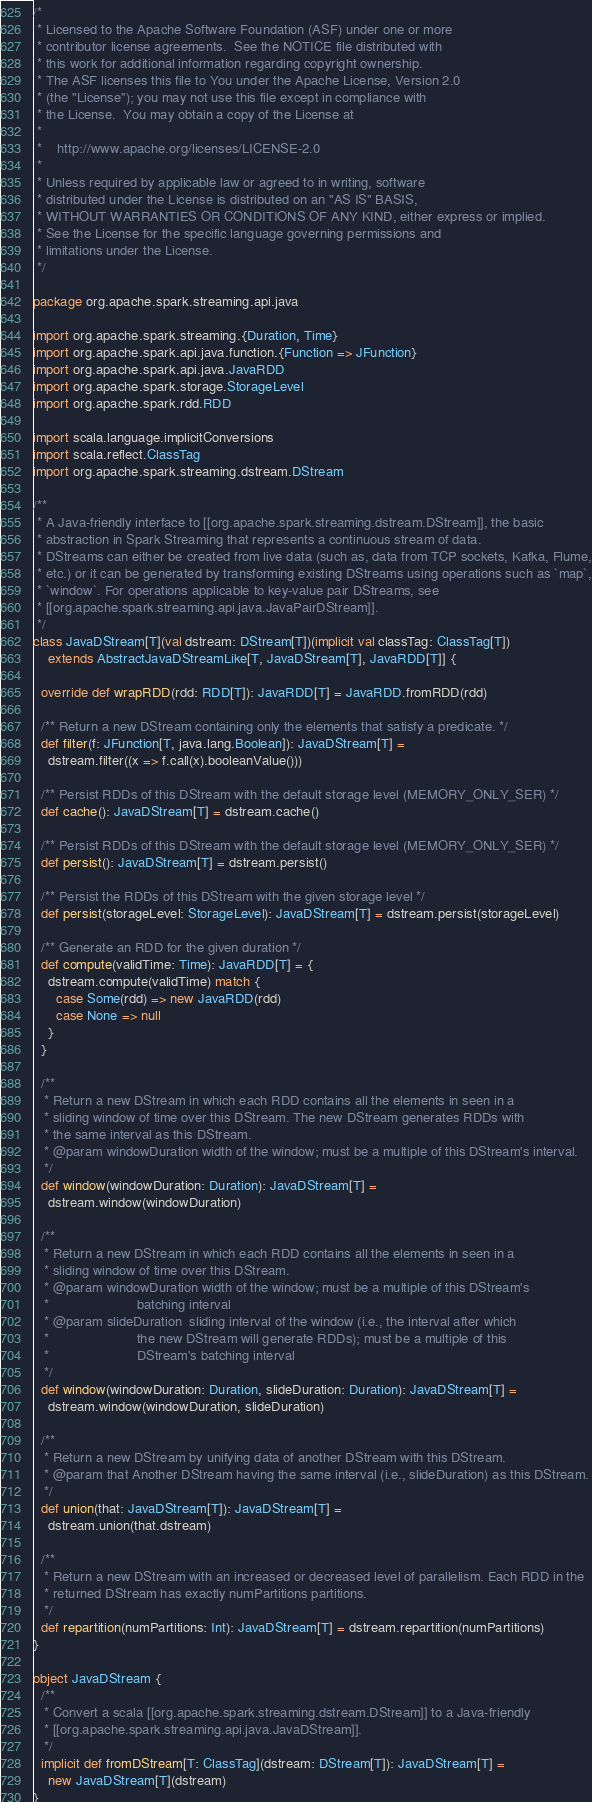<code> <loc_0><loc_0><loc_500><loc_500><_Scala_>/*
 * Licensed to the Apache Software Foundation (ASF) under one or more
 * contributor license agreements.  See the NOTICE file distributed with
 * this work for additional information regarding copyright ownership.
 * The ASF licenses this file to You under the Apache License, Version 2.0
 * (the "License"); you may not use this file except in compliance with
 * the License.  You may obtain a copy of the License at
 *
 *    http://www.apache.org/licenses/LICENSE-2.0
 *
 * Unless required by applicable law or agreed to in writing, software
 * distributed under the License is distributed on an "AS IS" BASIS,
 * WITHOUT WARRANTIES OR CONDITIONS OF ANY KIND, either express or implied.
 * See the License for the specific language governing permissions and
 * limitations under the License.
 */

package org.apache.spark.streaming.api.java

import org.apache.spark.streaming.{Duration, Time}
import org.apache.spark.api.java.function.{Function => JFunction}
import org.apache.spark.api.java.JavaRDD
import org.apache.spark.storage.StorageLevel
import org.apache.spark.rdd.RDD

import scala.language.implicitConversions
import scala.reflect.ClassTag
import org.apache.spark.streaming.dstream.DStream

/**
 * A Java-friendly interface to [[org.apache.spark.streaming.dstream.DStream]], the basic
 * abstraction in Spark Streaming that represents a continuous stream of data.
 * DStreams can either be created from live data (such as, data from TCP sockets, Kafka, Flume,
 * etc.) or it can be generated by transforming existing DStreams using operations such as `map`,
 * `window`. For operations applicable to key-value pair DStreams, see
 * [[org.apache.spark.streaming.api.java.JavaPairDStream]].
 */
class JavaDStream[T](val dstream: DStream[T])(implicit val classTag: ClassTag[T])
    extends AbstractJavaDStreamLike[T, JavaDStream[T], JavaRDD[T]] {

  override def wrapRDD(rdd: RDD[T]): JavaRDD[T] = JavaRDD.fromRDD(rdd)

  /** Return a new DStream containing only the elements that satisfy a predicate. */
  def filter(f: JFunction[T, java.lang.Boolean]): JavaDStream[T] =
    dstream.filter((x => f.call(x).booleanValue()))

  /** Persist RDDs of this DStream with the default storage level (MEMORY_ONLY_SER) */
  def cache(): JavaDStream[T] = dstream.cache()

  /** Persist RDDs of this DStream with the default storage level (MEMORY_ONLY_SER) */
  def persist(): JavaDStream[T] = dstream.persist()

  /** Persist the RDDs of this DStream with the given storage level */
  def persist(storageLevel: StorageLevel): JavaDStream[T] = dstream.persist(storageLevel)

  /** Generate an RDD for the given duration */
  def compute(validTime: Time): JavaRDD[T] = {
    dstream.compute(validTime) match {
      case Some(rdd) => new JavaRDD(rdd)
      case None => null
    }
  }

  /**
   * Return a new DStream in which each RDD contains all the elements in seen in a
   * sliding window of time over this DStream. The new DStream generates RDDs with
   * the same interval as this DStream.
   * @param windowDuration width of the window; must be a multiple of this DStream's interval.
   */
  def window(windowDuration: Duration): JavaDStream[T] =
    dstream.window(windowDuration)

  /**
   * Return a new DStream in which each RDD contains all the elements in seen in a
   * sliding window of time over this DStream.
   * @param windowDuration width of the window; must be a multiple of this DStream's
   *                       batching interval
   * @param slideDuration  sliding interval of the window (i.e., the interval after which
   *                       the new DStream will generate RDDs); must be a multiple of this
   *                       DStream's batching interval
   */
  def window(windowDuration: Duration, slideDuration: Duration): JavaDStream[T] =
    dstream.window(windowDuration, slideDuration)

  /**
   * Return a new DStream by unifying data of another DStream with this DStream.
   * @param that Another DStream having the same interval (i.e., slideDuration) as this DStream.
   */
  def union(that: JavaDStream[T]): JavaDStream[T] =
    dstream.union(that.dstream)

  /**
   * Return a new DStream with an increased or decreased level of parallelism. Each RDD in the
   * returned DStream has exactly numPartitions partitions.
   */
  def repartition(numPartitions: Int): JavaDStream[T] = dstream.repartition(numPartitions)
}

object JavaDStream {
  /**
   * Convert a scala [[org.apache.spark.streaming.dstream.DStream]] to a Java-friendly
   * [[org.apache.spark.streaming.api.java.JavaDStream]].
   */
  implicit def fromDStream[T: ClassTag](dstream: DStream[T]): JavaDStream[T] =
    new JavaDStream[T](dstream)
}
</code> 